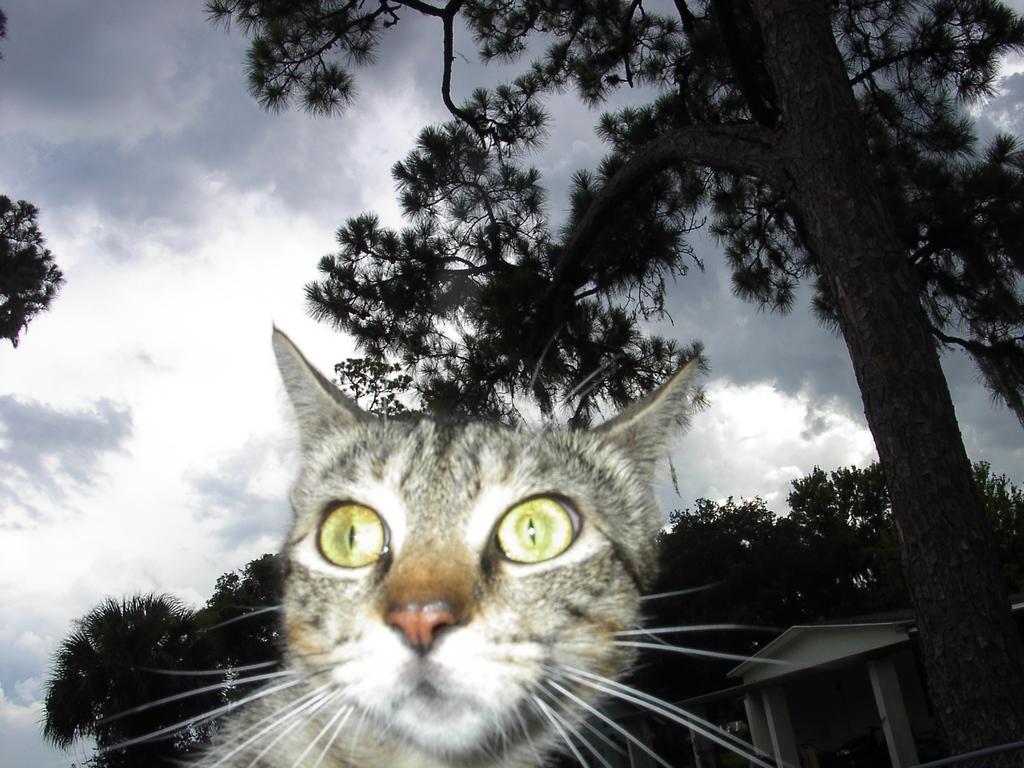Could you give a brief overview of what you see in this image? In this image I can see there is a cat. And at the back there are trees and building. And at the top there is a sky. 